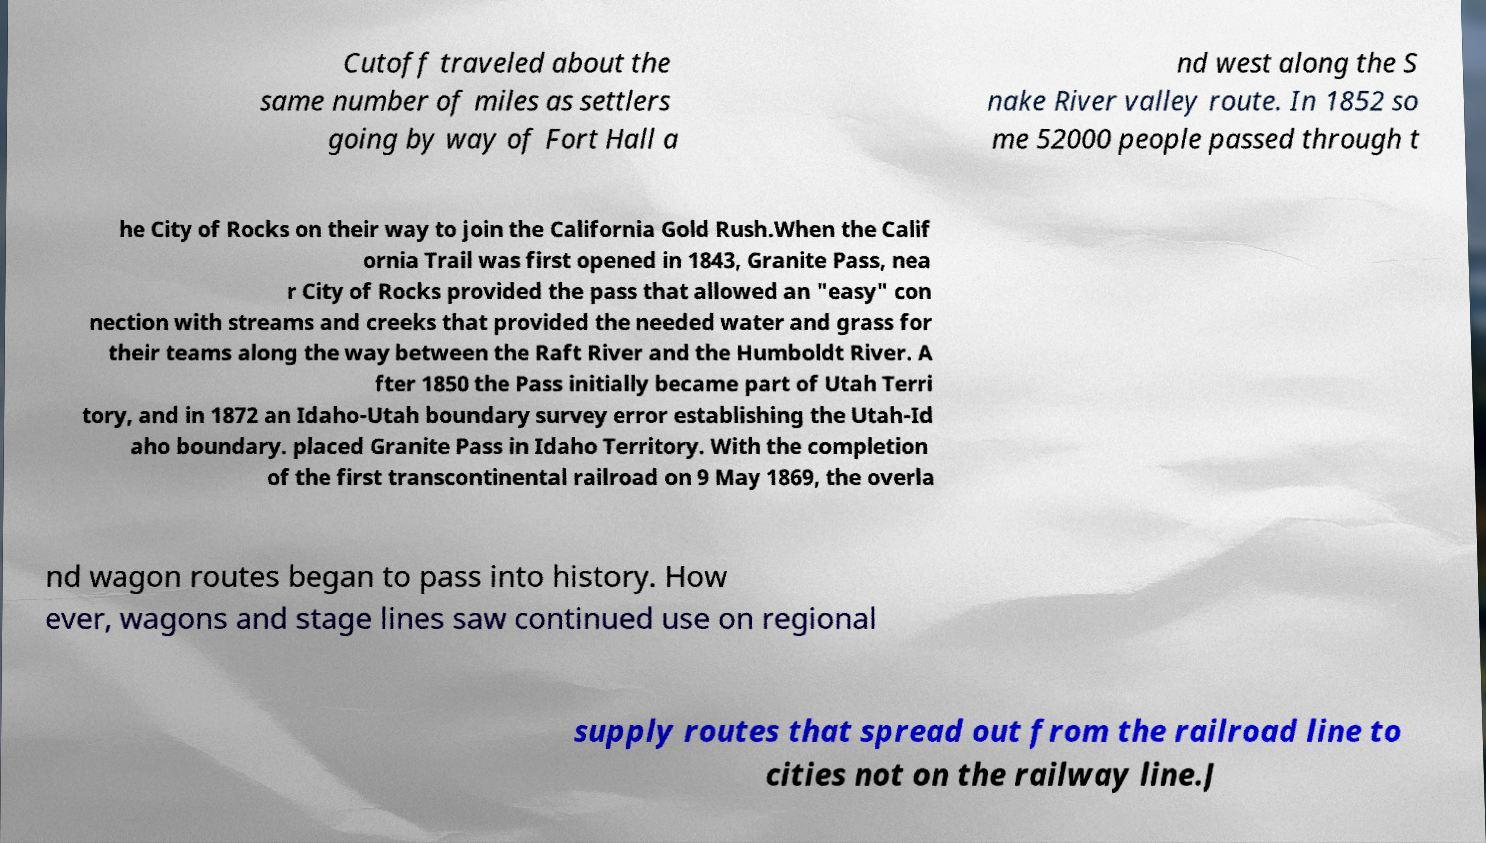For documentation purposes, I need the text within this image transcribed. Could you provide that? Cutoff traveled about the same number of miles as settlers going by way of Fort Hall a nd west along the S nake River valley route. In 1852 so me 52000 people passed through t he City of Rocks on their way to join the California Gold Rush.When the Calif ornia Trail was first opened in 1843, Granite Pass, nea r City of Rocks provided the pass that allowed an "easy" con nection with streams and creeks that provided the needed water and grass for their teams along the way between the Raft River and the Humboldt River. A fter 1850 the Pass initially became part of Utah Terri tory, and in 1872 an Idaho-Utah boundary survey error establishing the Utah-Id aho boundary. placed Granite Pass in Idaho Territory. With the completion of the first transcontinental railroad on 9 May 1869, the overla nd wagon routes began to pass into history. How ever, wagons and stage lines saw continued use on regional supply routes that spread out from the railroad line to cities not on the railway line.J 